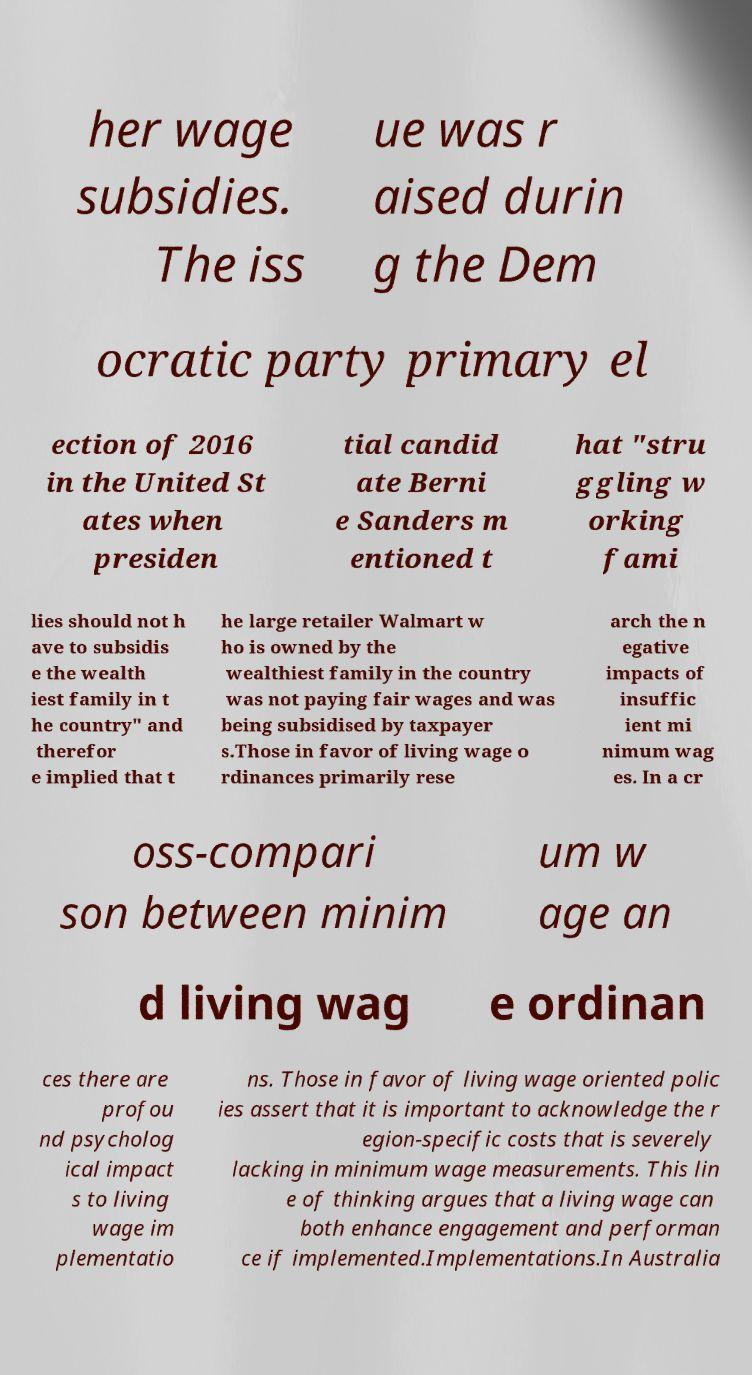Could you extract and type out the text from this image? her wage subsidies. The iss ue was r aised durin g the Dem ocratic party primary el ection of 2016 in the United St ates when presiden tial candid ate Berni e Sanders m entioned t hat "stru ggling w orking fami lies should not h ave to subsidis e the wealth iest family in t he country" and therefor e implied that t he large retailer Walmart w ho is owned by the wealthiest family in the country was not paying fair wages and was being subsidised by taxpayer s.Those in favor of living wage o rdinances primarily rese arch the n egative impacts of insuffic ient mi nimum wag es. In a cr oss-compari son between minim um w age an d living wag e ordinan ces there are profou nd psycholog ical impact s to living wage im plementatio ns. Those in favor of living wage oriented polic ies assert that it is important to acknowledge the r egion-specific costs that is severely lacking in minimum wage measurements. This lin e of thinking argues that a living wage can both enhance engagement and performan ce if implemented.Implementations.In Australia 